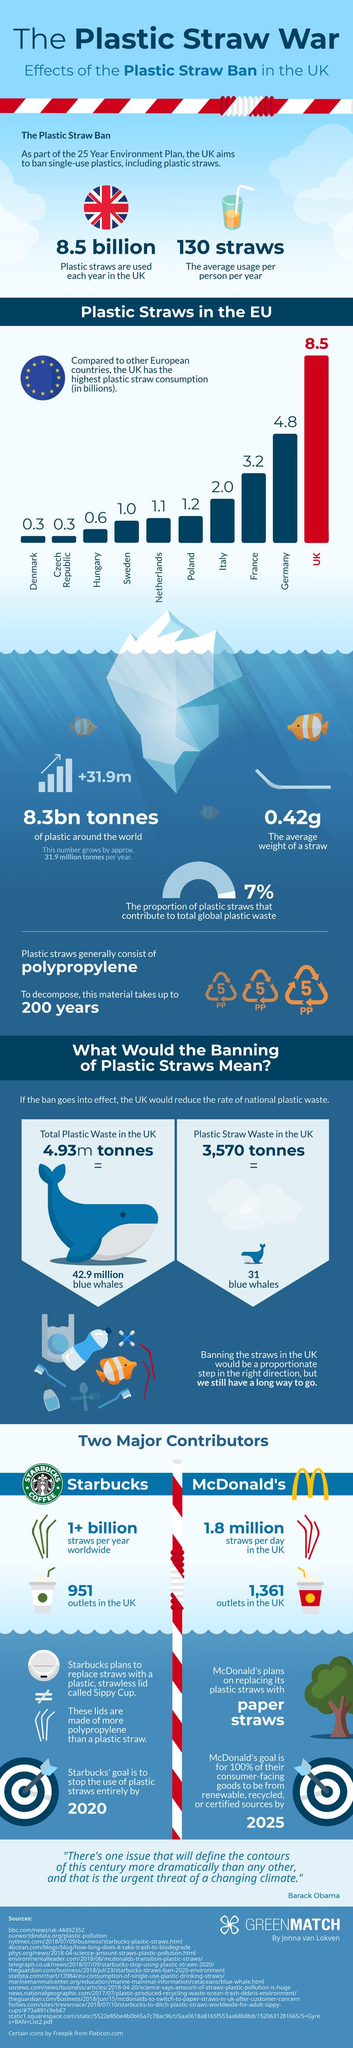Identify some key points in this picture. Research shows that each British citizen uses an average of 130 plastic straws annually. Plastic straws are made from a material called polypropylene. According to a recent study, only 7% of all plastic waste is made up of plastic straws, with the majority of plastic waste consisting of other items such as packaging and single-use bottles. Germany is the European country that ranks second in consumption of plastic straws. According to my research, only three European countries have plastic straw consumption rates below 1.0 billion. 